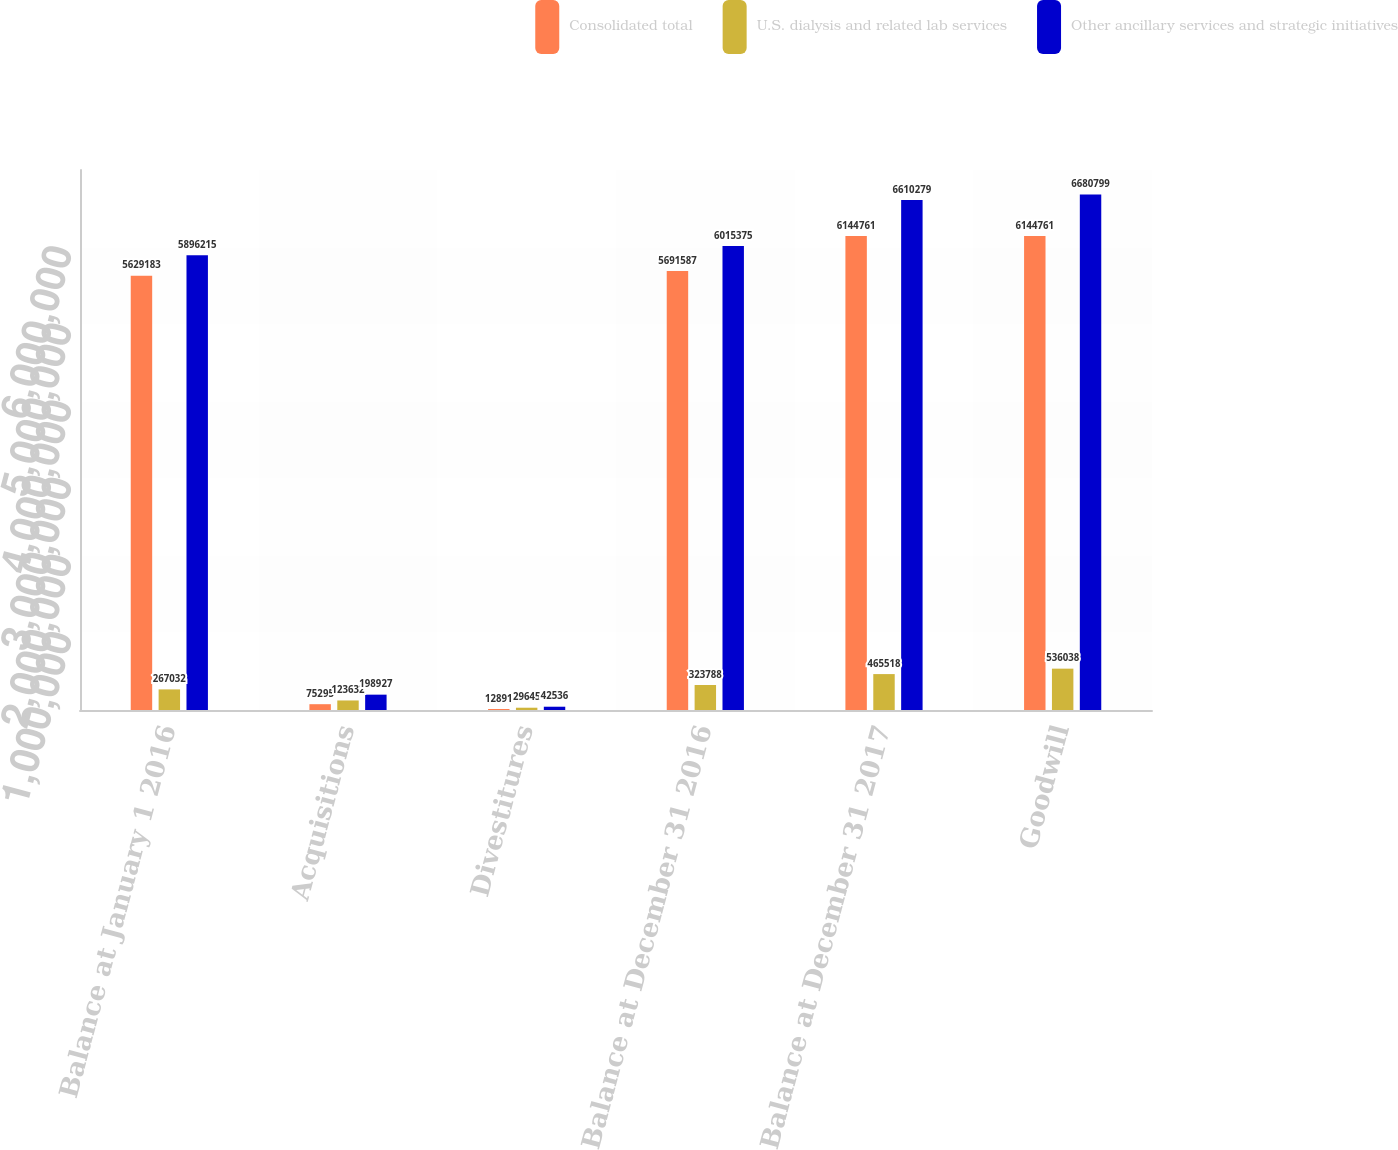Convert chart. <chart><loc_0><loc_0><loc_500><loc_500><stacked_bar_chart><ecel><fcel>Balance at January 1 2016<fcel>Acquisitions<fcel>Divestitures<fcel>Balance at December 31 2016<fcel>Balance at December 31 2017<fcel>Goodwill<nl><fcel>Consolidated total<fcel>5.62918e+06<fcel>75295<fcel>12891<fcel>5.69159e+06<fcel>6.14476e+06<fcel>6.14476e+06<nl><fcel>U.S. dialysis and related lab services<fcel>267032<fcel>123632<fcel>29645<fcel>323788<fcel>465518<fcel>536038<nl><fcel>Other ancillary services and strategic initiatives<fcel>5.89622e+06<fcel>198927<fcel>42536<fcel>6.01538e+06<fcel>6.61028e+06<fcel>6.6808e+06<nl></chart> 